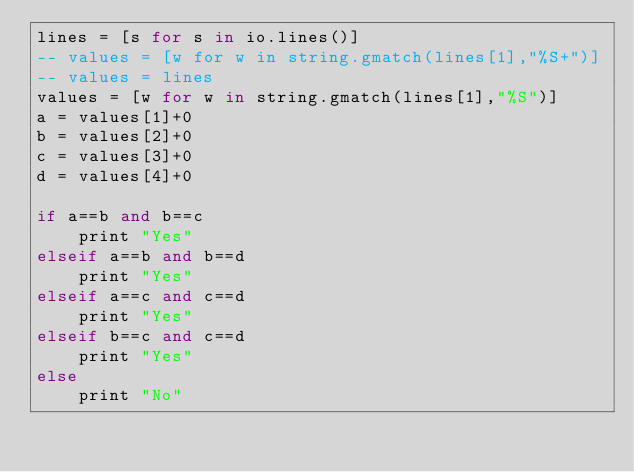Convert code to text. <code><loc_0><loc_0><loc_500><loc_500><_MoonScript_>lines = [s for s in io.lines()]
-- values = [w for w in string.gmatch(lines[1],"%S+")]
-- values = lines
values = [w for w in string.gmatch(lines[1],"%S")]
a = values[1]+0
b = values[2]+0
c = values[3]+0
d = values[4]+0

if a==b and b==c
	print "Yes"
elseif a==b and b==d
	print "Yes"
elseif a==c and c==d
	print "Yes"
elseif b==c and c==d
	print "Yes"
else
	print "No"
    </code> 